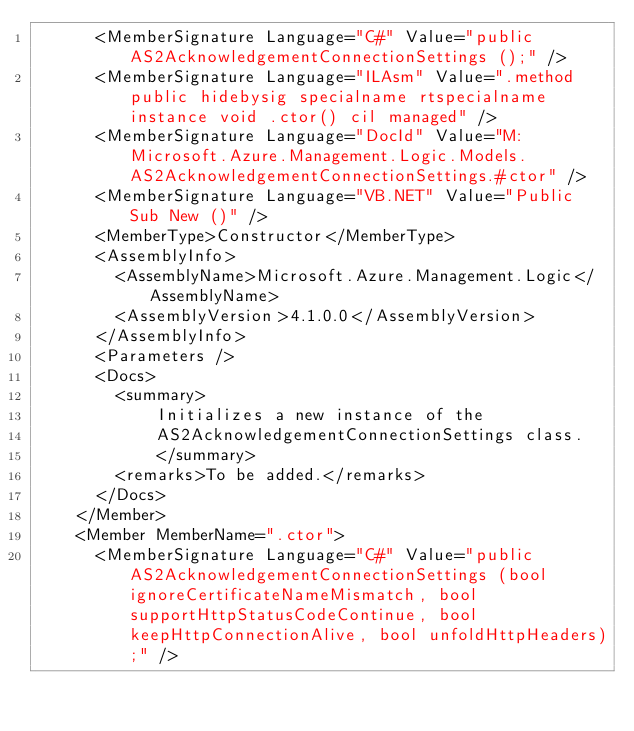<code> <loc_0><loc_0><loc_500><loc_500><_XML_>      <MemberSignature Language="C#" Value="public AS2AcknowledgementConnectionSettings ();" />
      <MemberSignature Language="ILAsm" Value=".method public hidebysig specialname rtspecialname instance void .ctor() cil managed" />
      <MemberSignature Language="DocId" Value="M:Microsoft.Azure.Management.Logic.Models.AS2AcknowledgementConnectionSettings.#ctor" />
      <MemberSignature Language="VB.NET" Value="Public Sub New ()" />
      <MemberType>Constructor</MemberType>
      <AssemblyInfo>
        <AssemblyName>Microsoft.Azure.Management.Logic</AssemblyName>
        <AssemblyVersion>4.1.0.0</AssemblyVersion>
      </AssemblyInfo>
      <Parameters />
      <Docs>
        <summary>
            Initializes a new instance of the
            AS2AcknowledgementConnectionSettings class.
            </summary>
        <remarks>To be added.</remarks>
      </Docs>
    </Member>
    <Member MemberName=".ctor">
      <MemberSignature Language="C#" Value="public AS2AcknowledgementConnectionSettings (bool ignoreCertificateNameMismatch, bool supportHttpStatusCodeContinue, bool keepHttpConnectionAlive, bool unfoldHttpHeaders);" /></code> 